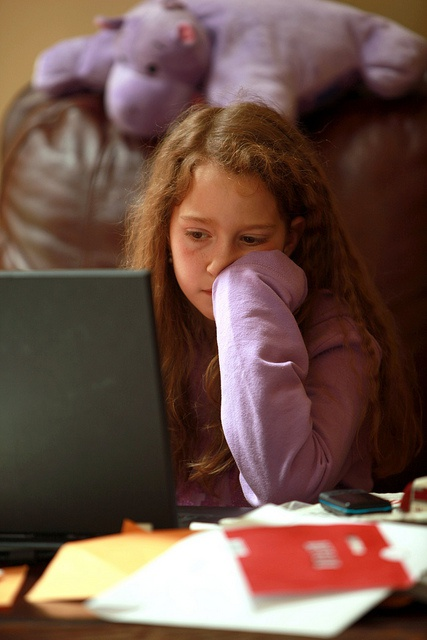Describe the objects in this image and their specific colors. I can see people in olive, black, maroon, and brown tones, laptop in olive and black tones, chair in olive, black, gray, and maroon tones, teddy bear in olive, darkgray, brown, maroon, and gray tones, and cell phone in olive, black, gray, and teal tones in this image. 